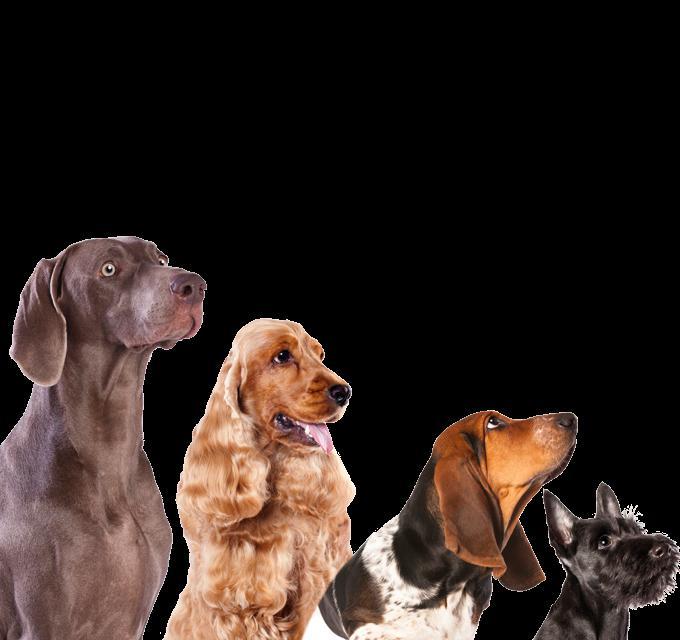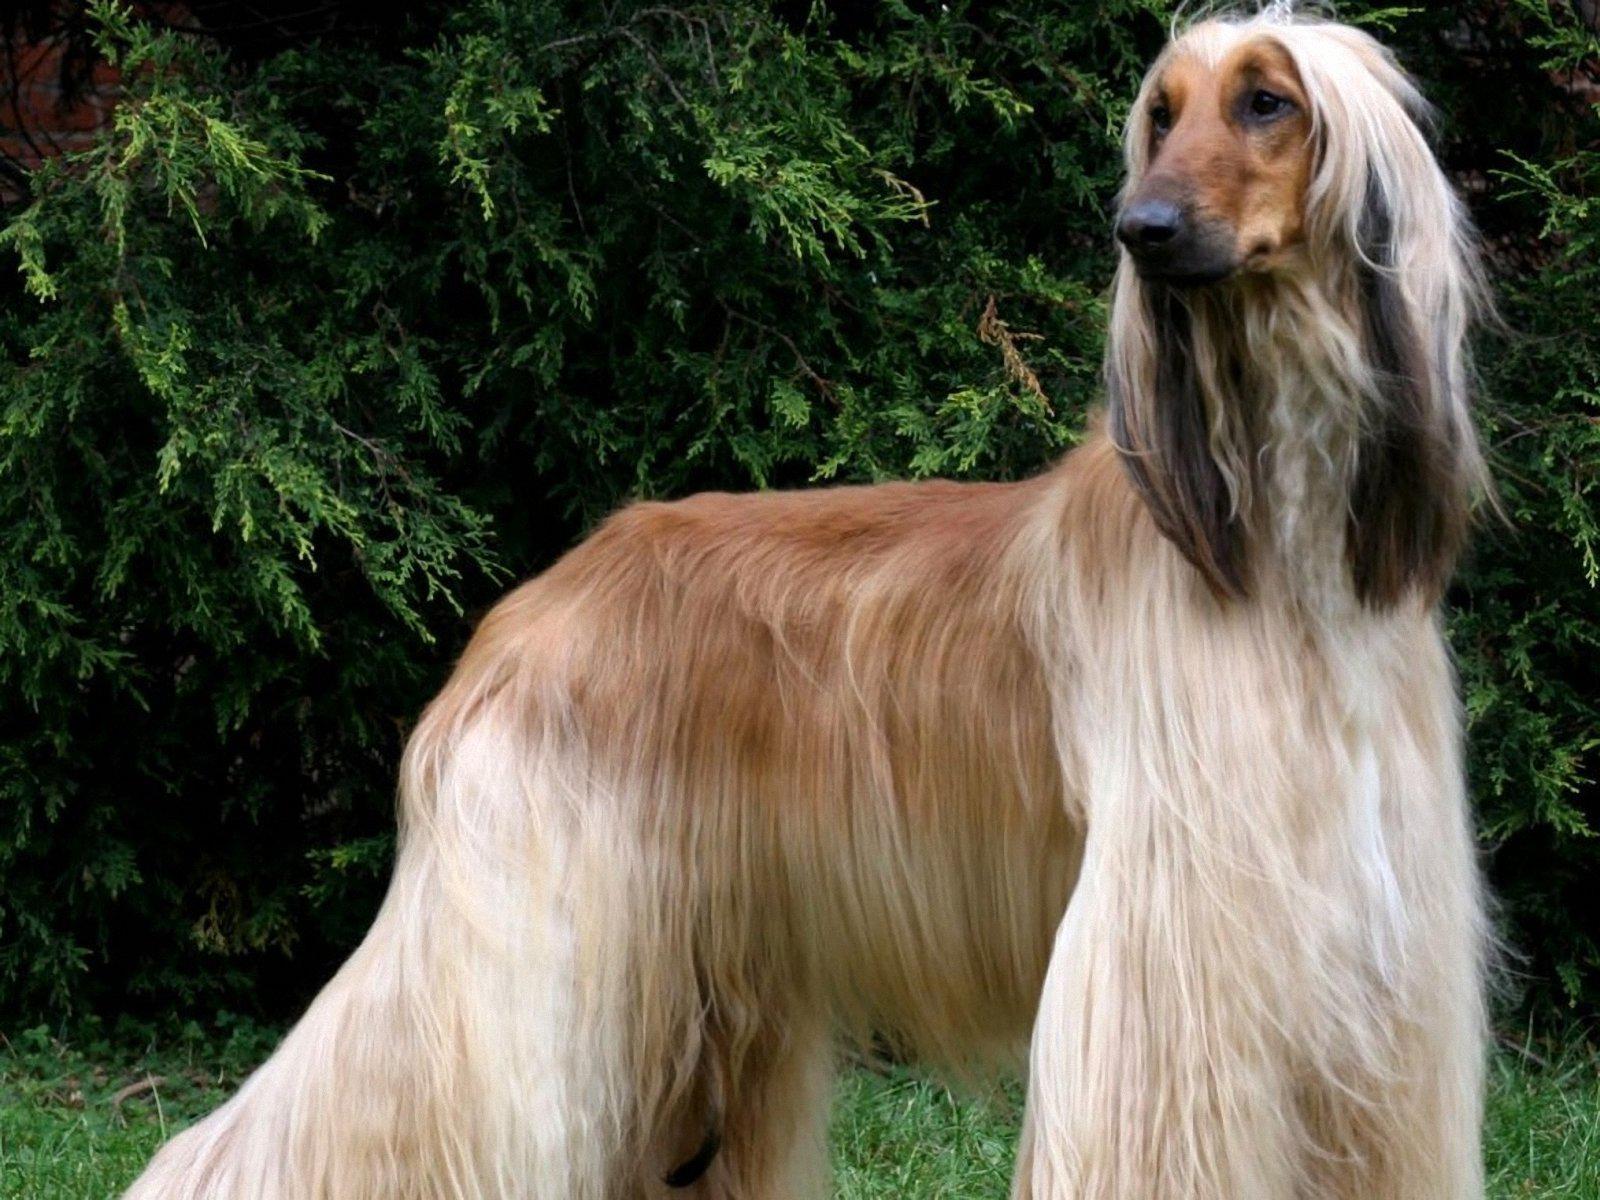The first image is the image on the left, the second image is the image on the right. For the images shown, is this caption "The dog in the image on the right is turned toward and facing the camera." true? Answer yes or no. No. 